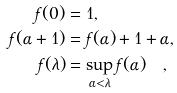<formula> <loc_0><loc_0><loc_500><loc_500>f ( 0 ) & = 1 , \\ f ( \alpha + 1 ) & = f ( \alpha ) + 1 + \alpha , \\ f ( \lambda ) & = \sup _ { \alpha < \lambda } f ( \alpha ) \quad ,</formula> 